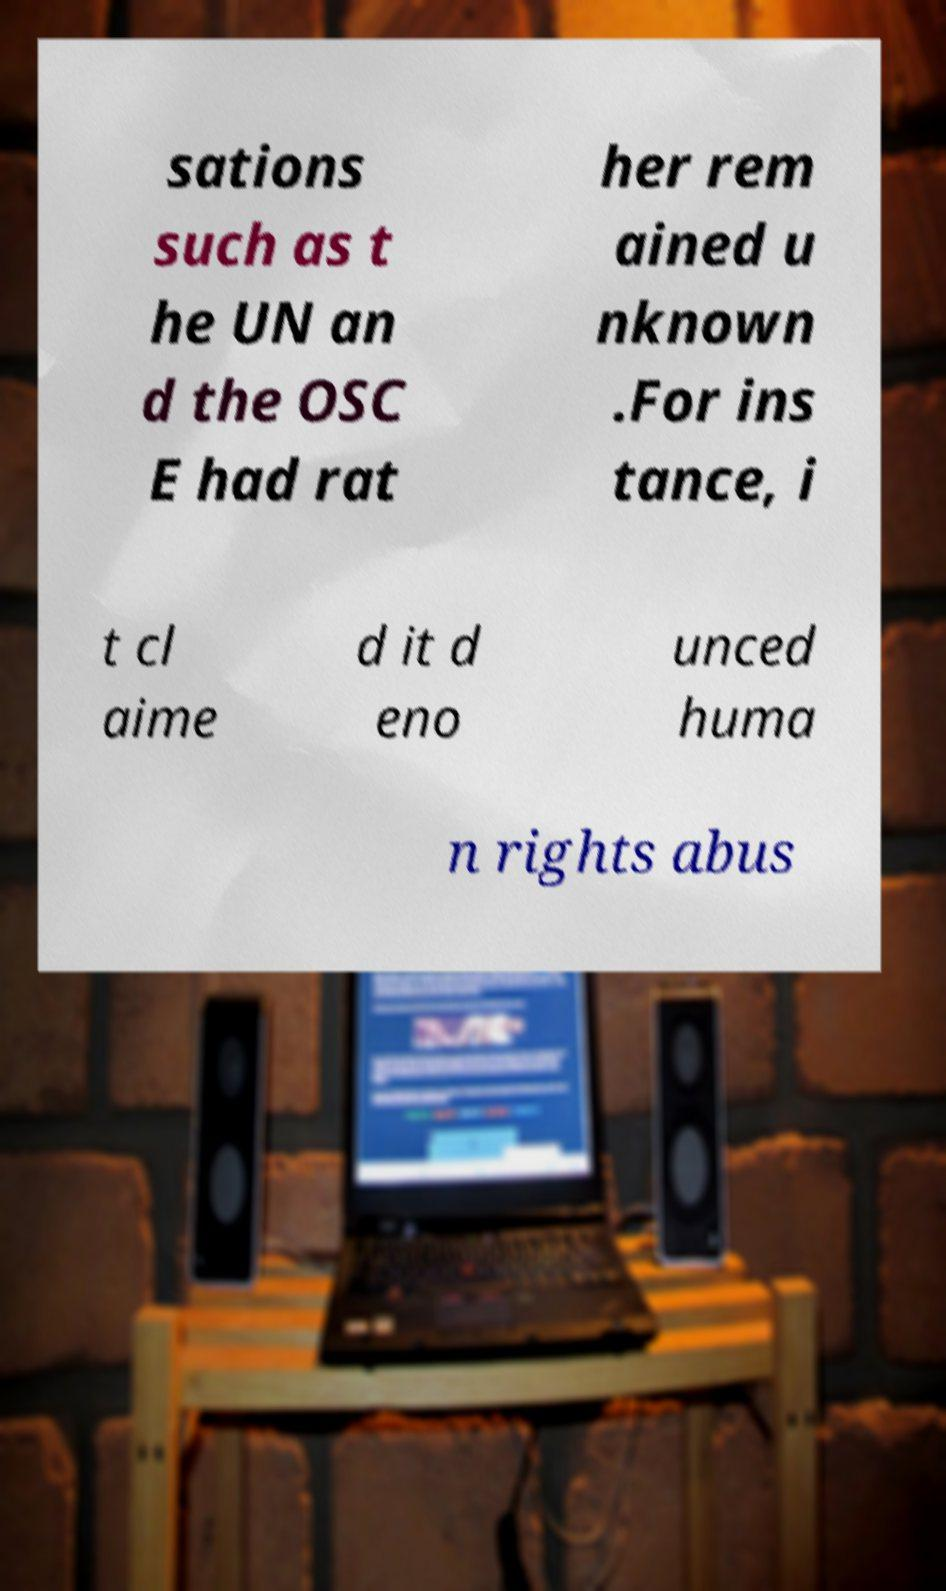There's text embedded in this image that I need extracted. Can you transcribe it verbatim? sations such as t he UN an d the OSC E had rat her rem ained u nknown .For ins tance, i t cl aime d it d eno unced huma n rights abus 